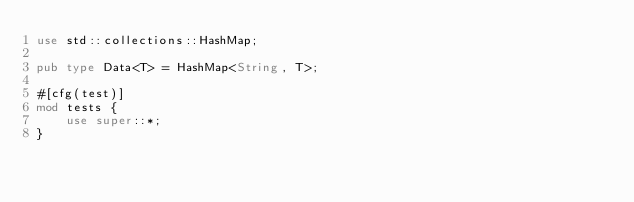<code> <loc_0><loc_0><loc_500><loc_500><_Rust_>use std::collections::HashMap;

pub type Data<T> = HashMap<String, T>;

#[cfg(test)]
mod tests {
    use super::*;
}
</code> 